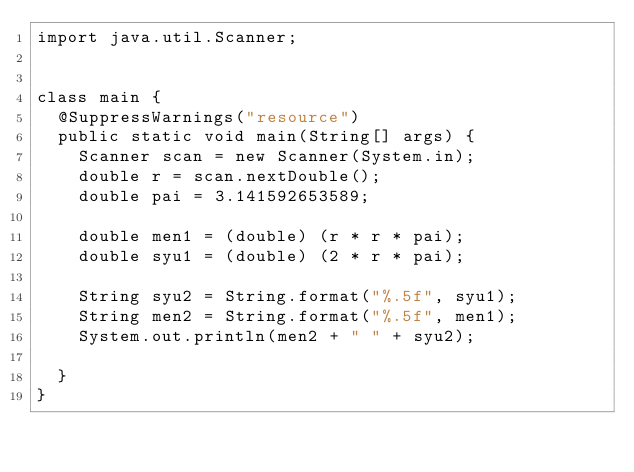Convert code to text. <code><loc_0><loc_0><loc_500><loc_500><_Java_>import java.util.Scanner;


class main {
	@SuppressWarnings("resource")
	public static void main(String[] args) {
		Scanner scan = new Scanner(System.in);
		double r = scan.nextDouble();
		double pai = 3.141592653589;
		
		double men1 = (double) (r * r * pai);
		double syu1 = (double) (2 * r * pai);
		
		String syu2 = String.format("%.5f", syu1);
		String men2 = String.format("%.5f", men1);
		System.out.println(men2 + " " + syu2);
		
	}
}</code> 